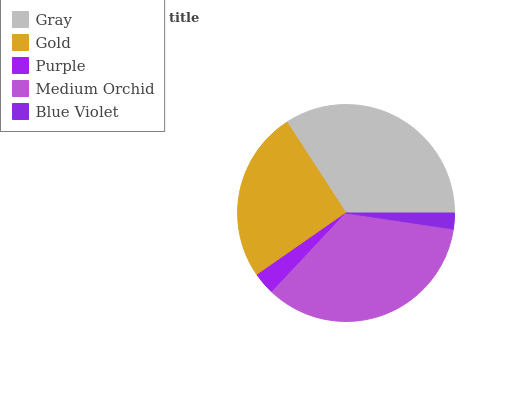Is Blue Violet the minimum?
Answer yes or no. Yes. Is Medium Orchid the maximum?
Answer yes or no. Yes. Is Gold the minimum?
Answer yes or no. No. Is Gold the maximum?
Answer yes or no. No. Is Gray greater than Gold?
Answer yes or no. Yes. Is Gold less than Gray?
Answer yes or no. Yes. Is Gold greater than Gray?
Answer yes or no. No. Is Gray less than Gold?
Answer yes or no. No. Is Gold the high median?
Answer yes or no. Yes. Is Gold the low median?
Answer yes or no. Yes. Is Gray the high median?
Answer yes or no. No. Is Blue Violet the low median?
Answer yes or no. No. 